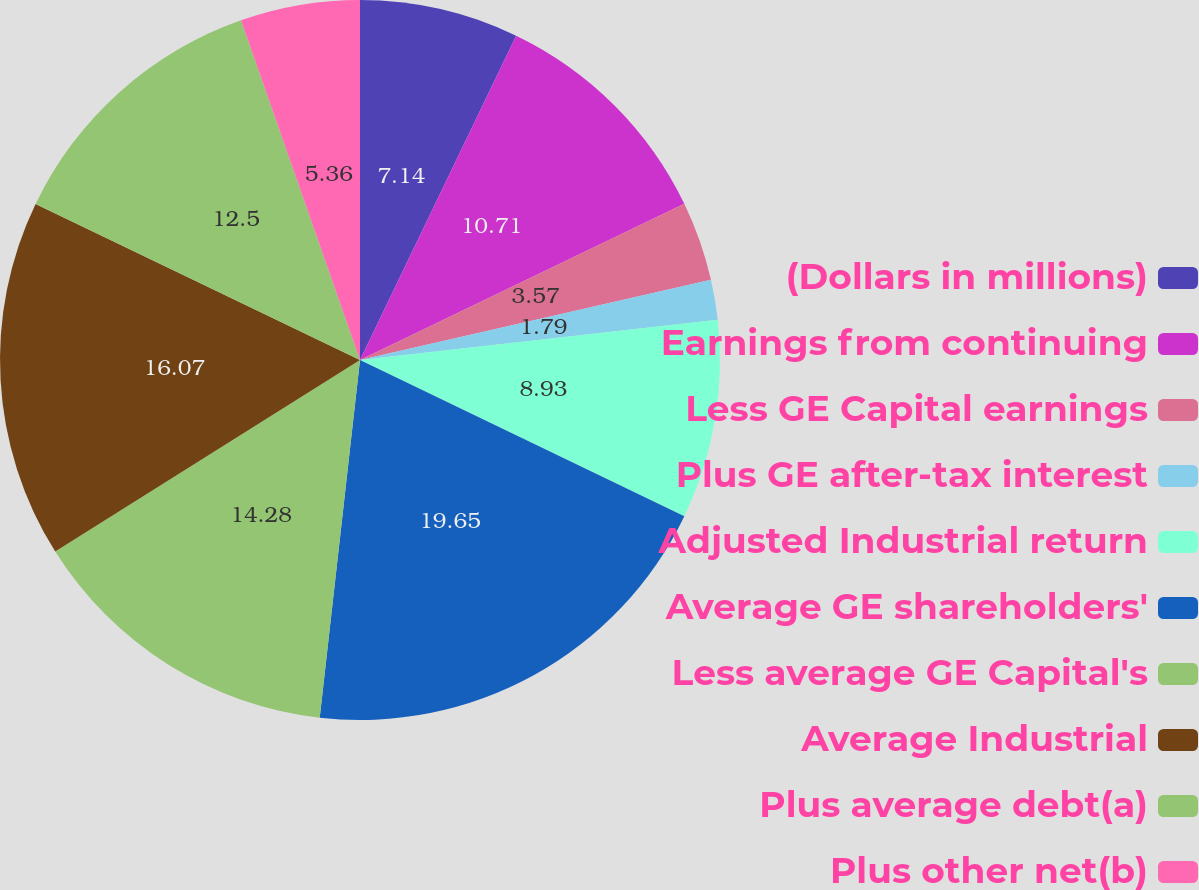<chart> <loc_0><loc_0><loc_500><loc_500><pie_chart><fcel>(Dollars in millions)<fcel>Earnings from continuing<fcel>Less GE Capital earnings<fcel>Plus GE after-tax interest<fcel>Adjusted Industrial return<fcel>Average GE shareholders'<fcel>Less average GE Capital's<fcel>Average Industrial<fcel>Plus average debt(a)<fcel>Plus other net(b)<nl><fcel>7.14%<fcel>10.71%<fcel>3.57%<fcel>1.79%<fcel>8.93%<fcel>19.64%<fcel>14.28%<fcel>16.07%<fcel>12.5%<fcel>5.36%<nl></chart> 